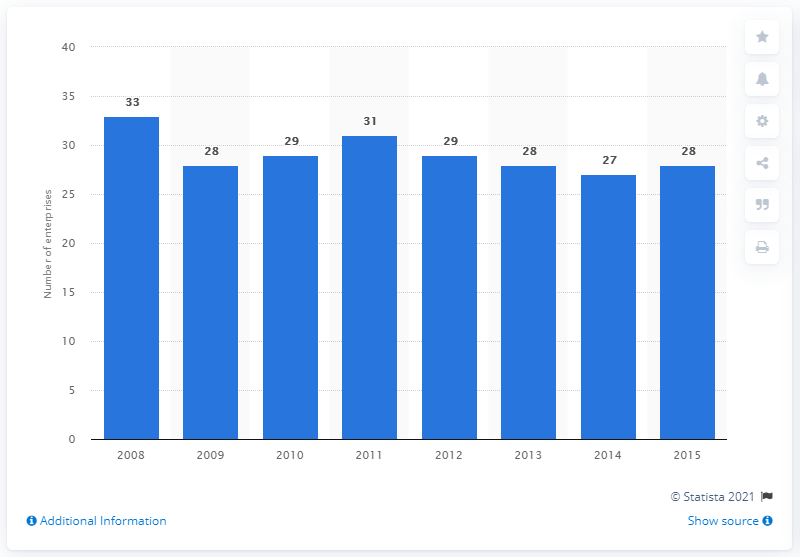Indicate a few pertinent items in this graphic. In 2015, there were 28 enterprises operating in the soap and detergents manufacturing industry in the United States. 